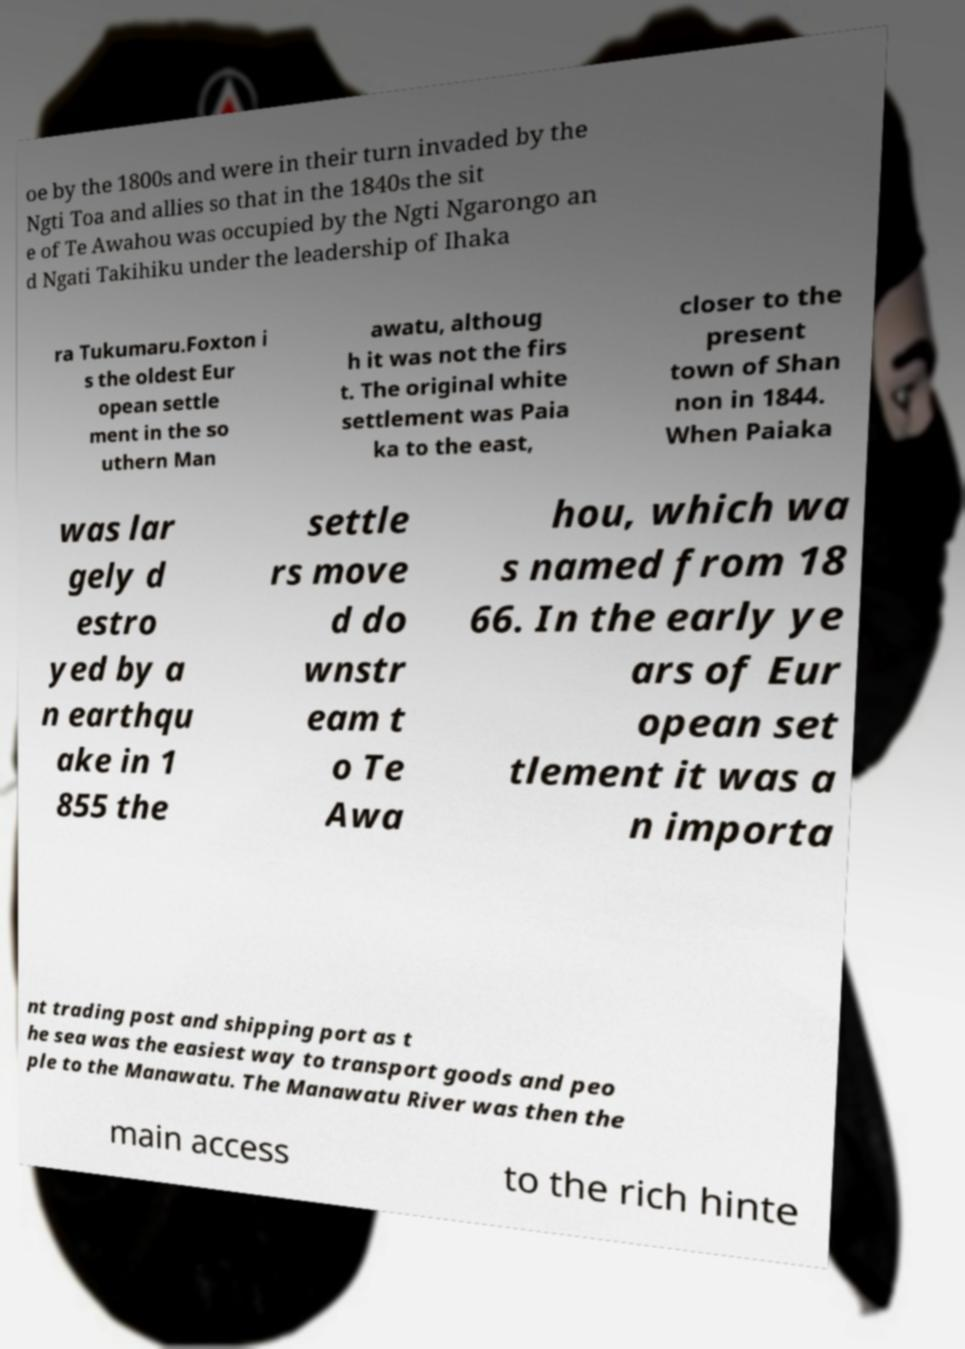Can you read and provide the text displayed in the image?This photo seems to have some interesting text. Can you extract and type it out for me? oe by the 1800s and were in their turn invaded by the Ngti Toa and allies so that in the 1840s the sit e of Te Awahou was occupied by the Ngti Ngarongo an d Ngati Takihiku under the leadership of Ihaka ra Tukumaru.Foxton i s the oldest Eur opean settle ment in the so uthern Man awatu, althoug h it was not the firs t. The original white settlement was Paia ka to the east, closer to the present town of Shan non in 1844. When Paiaka was lar gely d estro yed by a n earthqu ake in 1 855 the settle rs move d do wnstr eam t o Te Awa hou, which wa s named from 18 66. In the early ye ars of Eur opean set tlement it was a n importa nt trading post and shipping port as t he sea was the easiest way to transport goods and peo ple to the Manawatu. The Manawatu River was then the main access to the rich hinte 